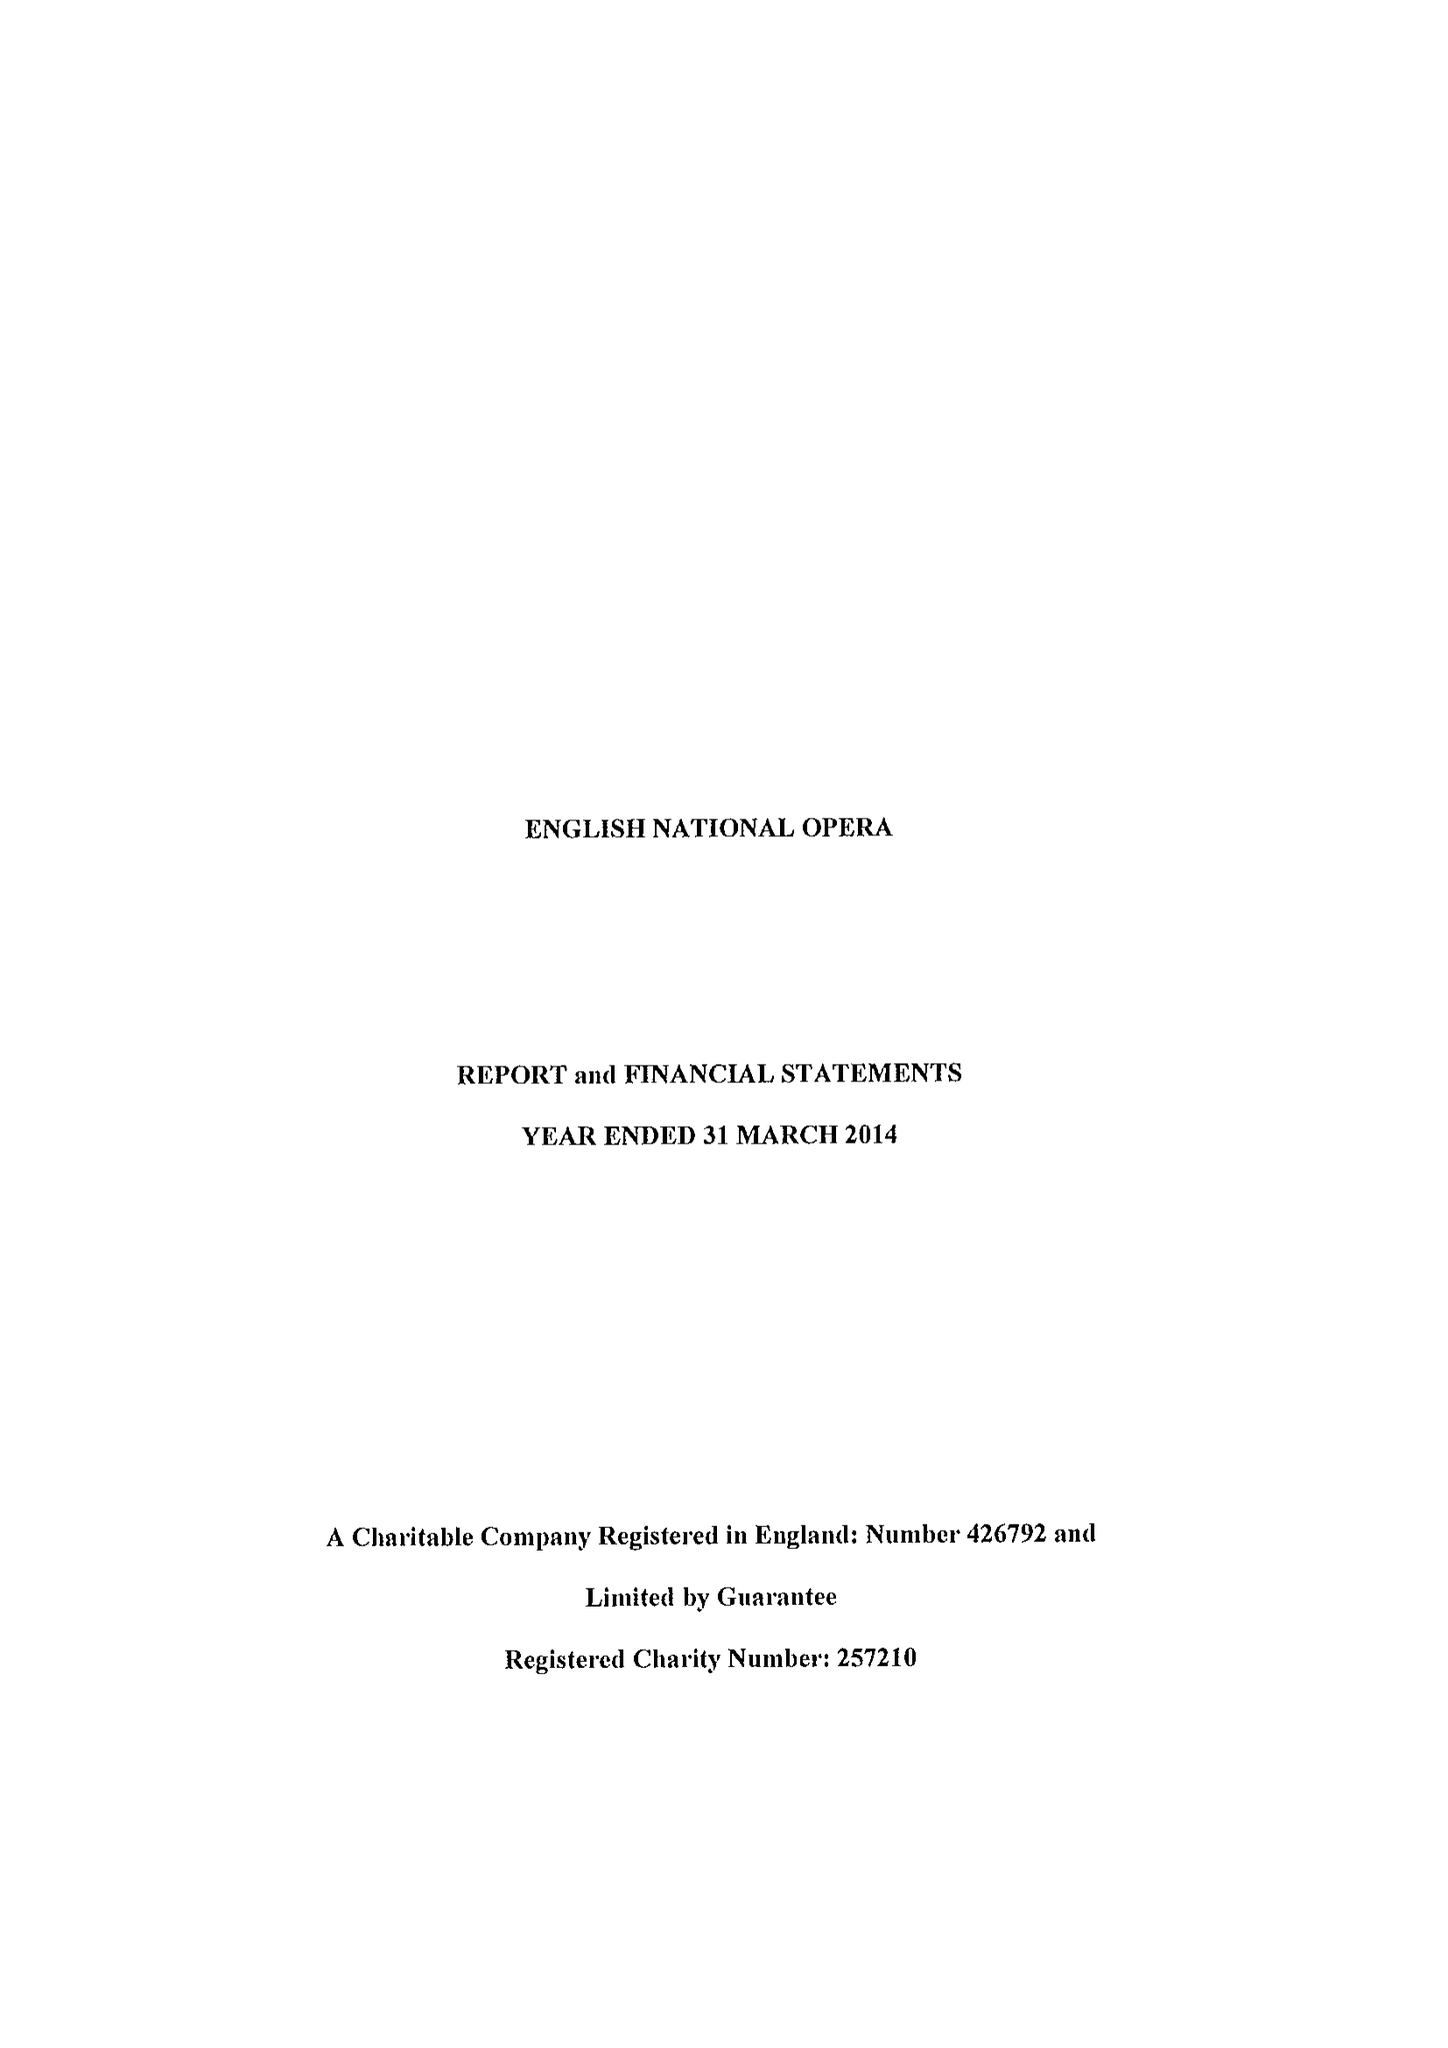What is the value for the address__post_town?
Answer the question using a single word or phrase. LONDON 